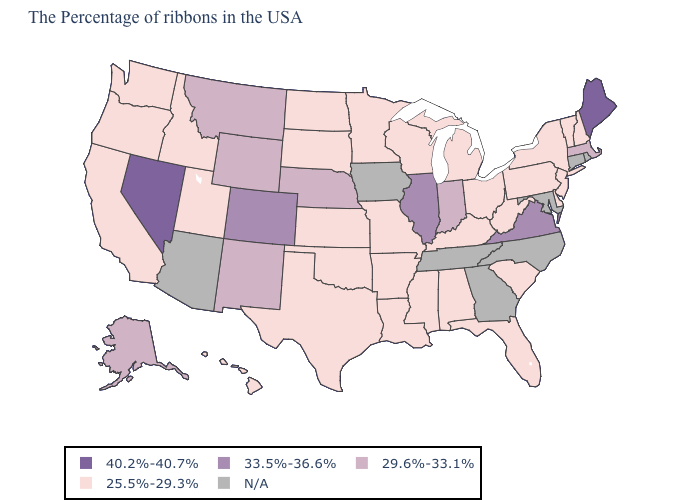What is the value of New Hampshire?
Concise answer only. 25.5%-29.3%. Is the legend a continuous bar?
Keep it brief. No. Does New Jersey have the highest value in the Northeast?
Be succinct. No. Among the states that border Massachusetts , which have the highest value?
Keep it brief. New Hampshire, Vermont, New York. Does New Mexico have the lowest value in the USA?
Write a very short answer. No. What is the lowest value in the West?
Keep it brief. 25.5%-29.3%. What is the value of New Hampshire?
Answer briefly. 25.5%-29.3%. What is the value of Idaho?
Be succinct. 25.5%-29.3%. What is the value of Idaho?
Answer briefly. 25.5%-29.3%. What is the lowest value in states that border Maine?
Give a very brief answer. 25.5%-29.3%. Name the states that have a value in the range 29.6%-33.1%?
Quick response, please. Massachusetts, Indiana, Nebraska, Wyoming, New Mexico, Montana, Alaska. What is the lowest value in the Northeast?
Short answer required. 25.5%-29.3%. 